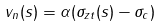Convert formula to latex. <formula><loc_0><loc_0><loc_500><loc_500>v _ { n } ( s ) = \alpha ( \sigma _ { z t } ( s ) - \sigma _ { c } )</formula> 